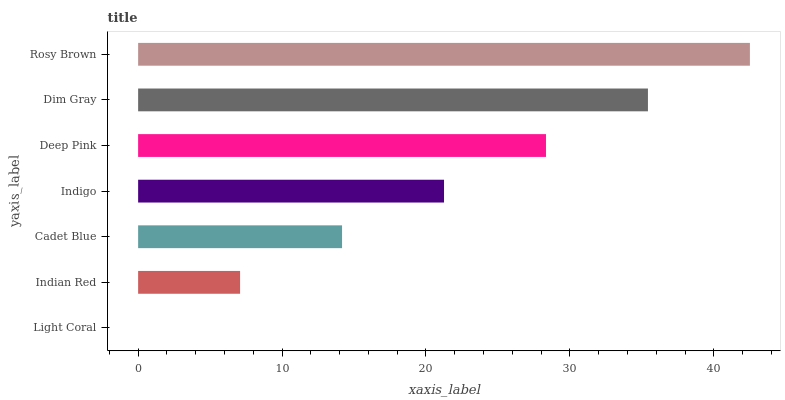Is Light Coral the minimum?
Answer yes or no. Yes. Is Rosy Brown the maximum?
Answer yes or no. Yes. Is Indian Red the minimum?
Answer yes or no. No. Is Indian Red the maximum?
Answer yes or no. No. Is Indian Red greater than Light Coral?
Answer yes or no. Yes. Is Light Coral less than Indian Red?
Answer yes or no. Yes. Is Light Coral greater than Indian Red?
Answer yes or no. No. Is Indian Red less than Light Coral?
Answer yes or no. No. Is Indigo the high median?
Answer yes or no. Yes. Is Indigo the low median?
Answer yes or no. Yes. Is Deep Pink the high median?
Answer yes or no. No. Is Rosy Brown the low median?
Answer yes or no. No. 